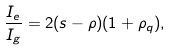Convert formula to latex. <formula><loc_0><loc_0><loc_500><loc_500>\frac { I _ { e } } { I _ { g } } = 2 ( s - \rho ) ( 1 + \rho _ { q } ) ,</formula> 